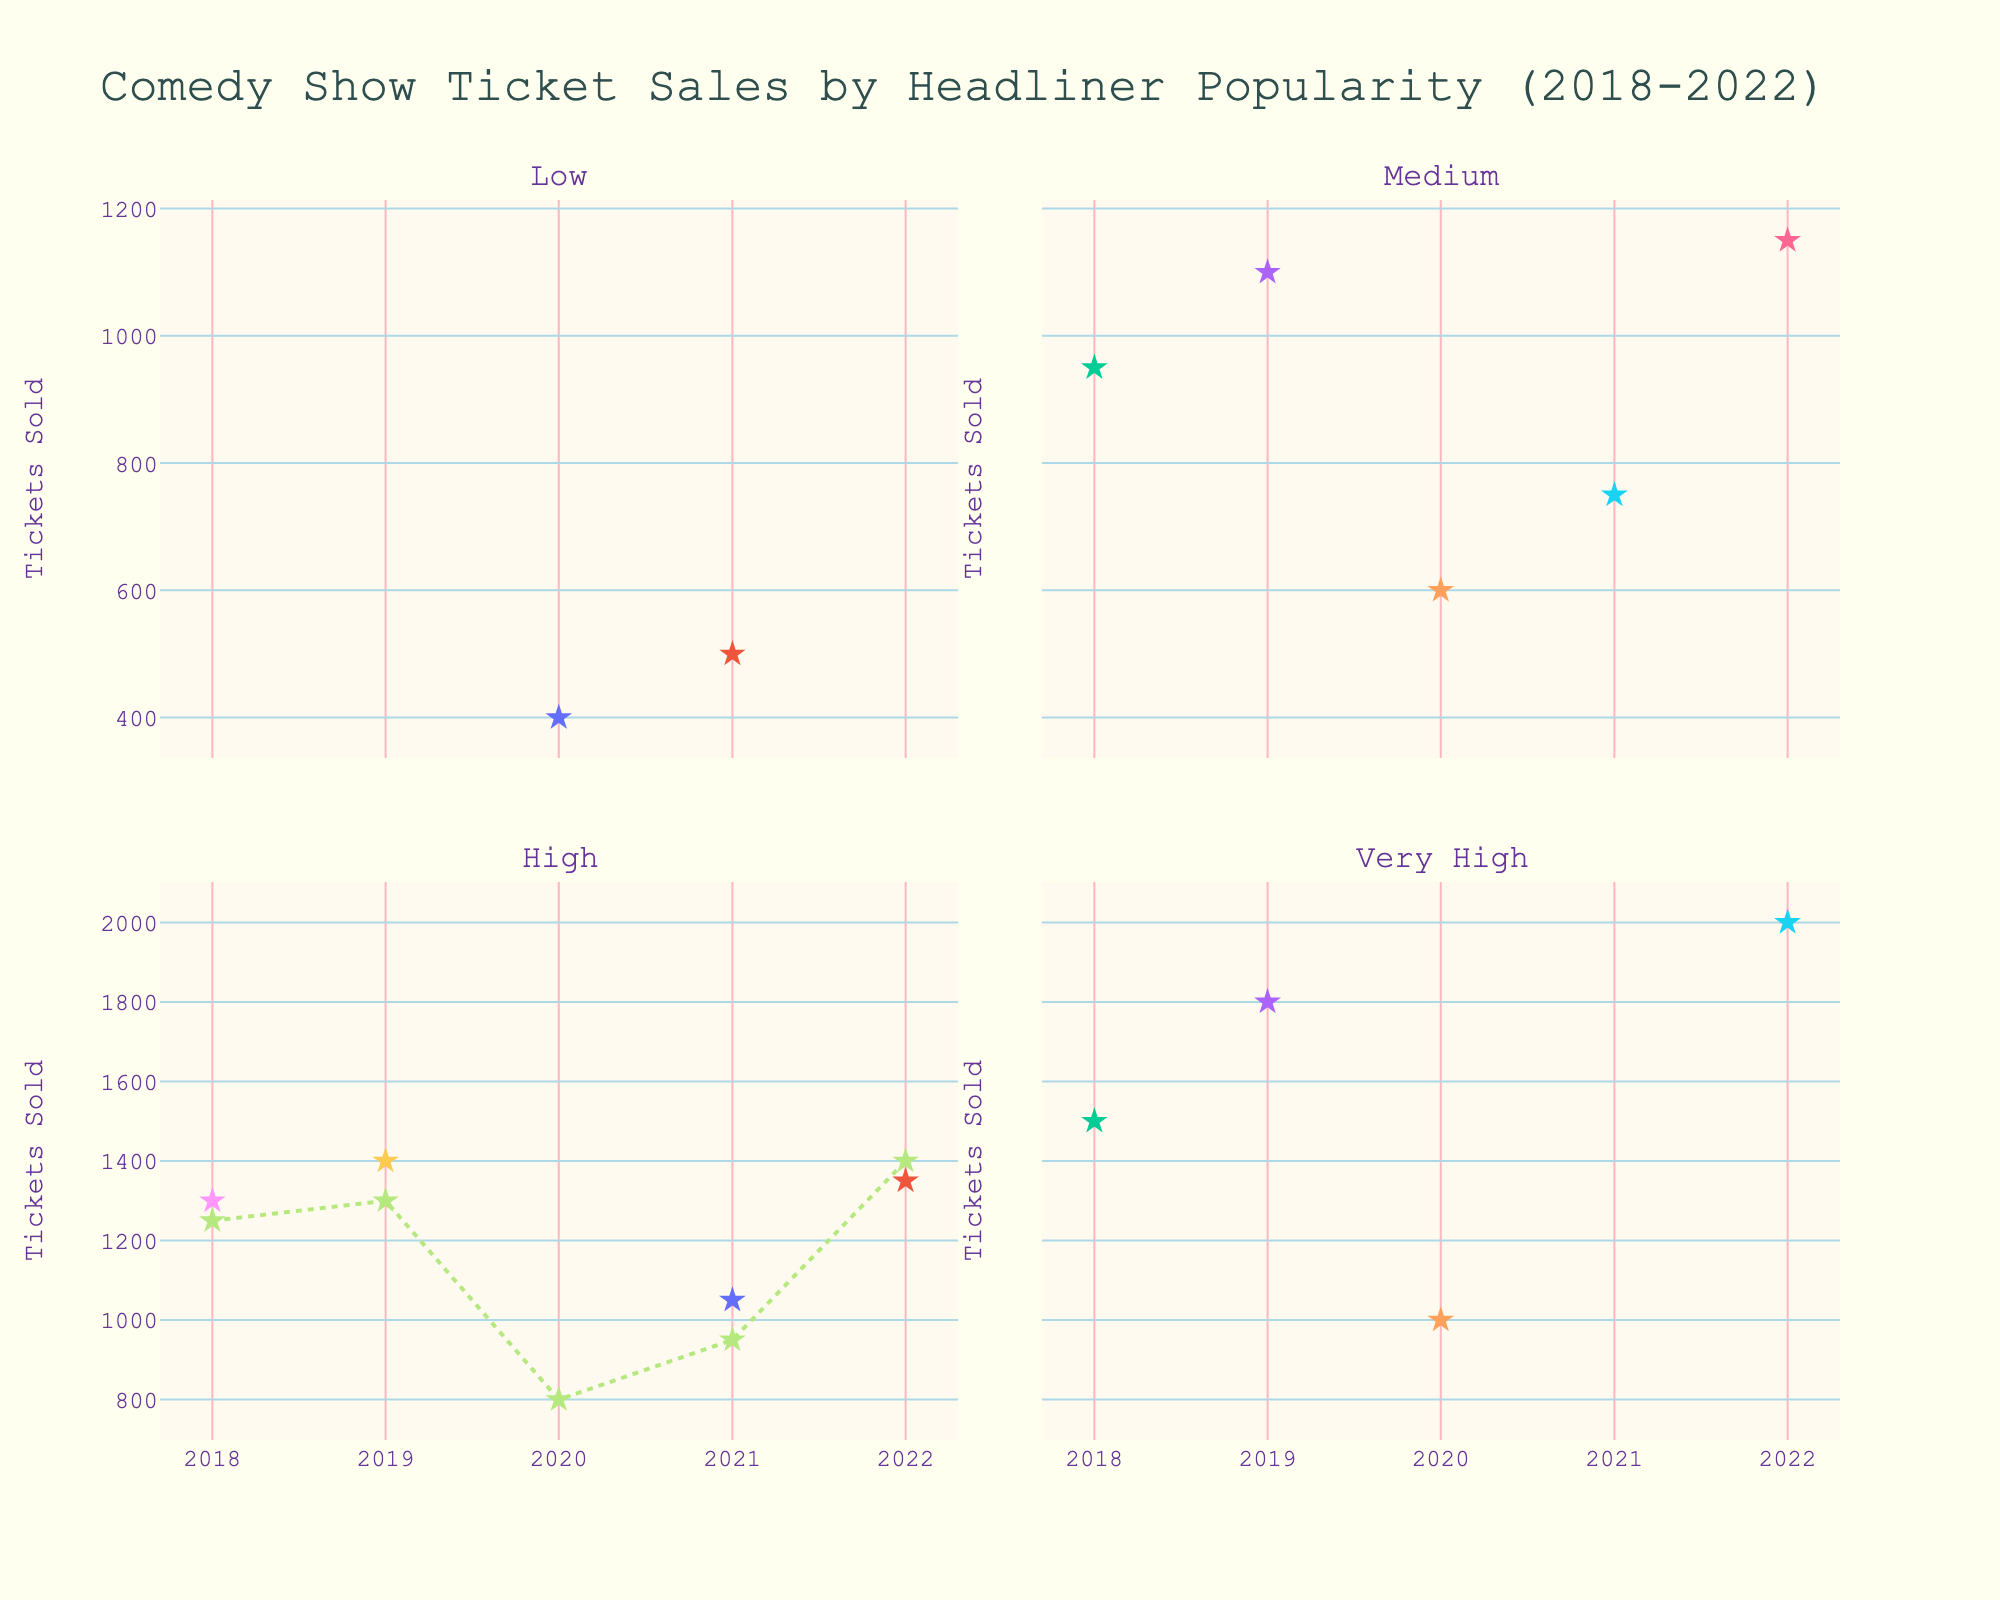Which headliner in the 'High' popularity category sold the most tickets in 2018? In the 'High' category subplot, look at the markers for different headliners in 2018. The highest marker corresponds to John Bishop with 1300 tickets sold.
Answer: John Bishop How did Ed Byrne's ticket sales trend from 2018 to 2022? Examine the 'High' popularity subplot and notice the markers for Ed Byrne. His ticket sales went from 1250 in 2018, increased to 1300 in 2019, dropped significantly to 800 in 2020, rose to 950 in 2021, and peaked at 1400 in 2022.
Answer: Increased after a dip in 2020 Which popularity category showed a consistent increase in ticket sales from 2018 to 2022? Look at each subplot to identify trends. Only the 'Very High' popularity category shows a consistent increase with ticket sales rising each year.
Answer: Very High What's the total number of tickets sold by Kevin Bridges and Ricky Gervais? Check the 'Very High' popularity subplot. Kevin Bridges sold 1000 tickets in 2020 and Ricky Gervais sold 2000 tickets in 2022. Adding these values gives 3000.
Answer: 3000 Who sold the least tickets in the 'Low' popularity category, and in what year? In the 'Low' popularity subplot, examine the markers. Sara Pascoe in 2020 sold the fewest tickets with 400.
Answer: Sara Pascoe in 2020 In the 'Medium' popularity category, whose ticket sales declined the most from the first to the last year? Look at the markers in the 'Medium' popularity subplot for 2018 and 2022. Romesh Ranganathan had the most significant decline, from 600 in 2020 to 400 in 2022.
Answer: Romesh Ranganathan What is the average number of tickets sold by all headliners in the 'High' popularity category in 2019? In the 'High' popularity subplot for 2019, the ticket numbers are 1300 for Ed Byrne and 1400 for Russell Howard. The sum is 2700. The average is 2700 / 2 = 1350.
Answer: 1350 